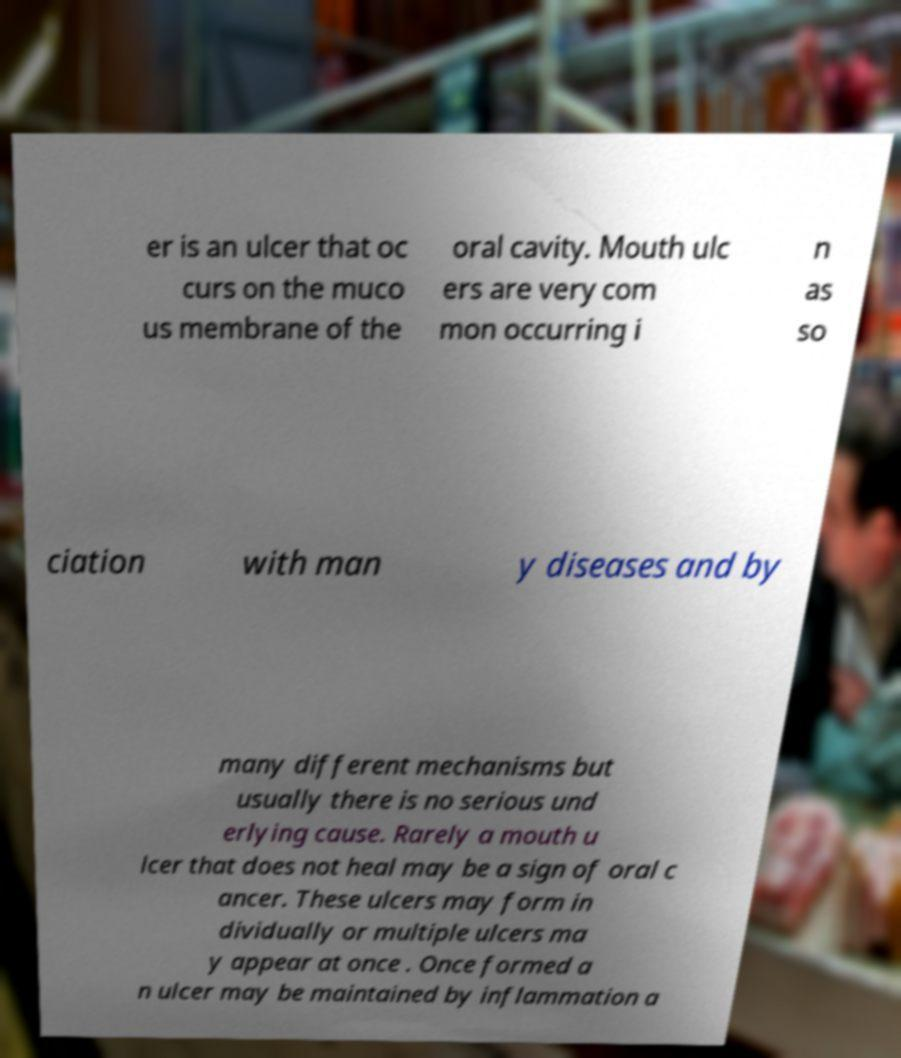What messages or text are displayed in this image? I need them in a readable, typed format. er is an ulcer that oc curs on the muco us membrane of the oral cavity. Mouth ulc ers are very com mon occurring i n as so ciation with man y diseases and by many different mechanisms but usually there is no serious und erlying cause. Rarely a mouth u lcer that does not heal may be a sign of oral c ancer. These ulcers may form in dividually or multiple ulcers ma y appear at once . Once formed a n ulcer may be maintained by inflammation a 